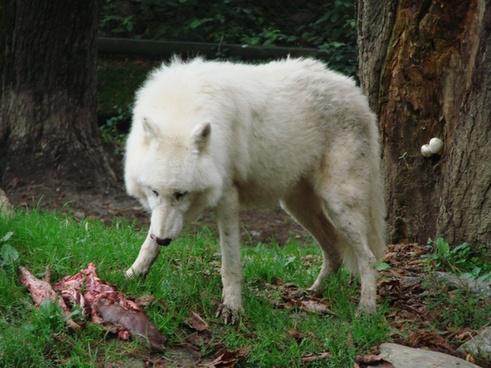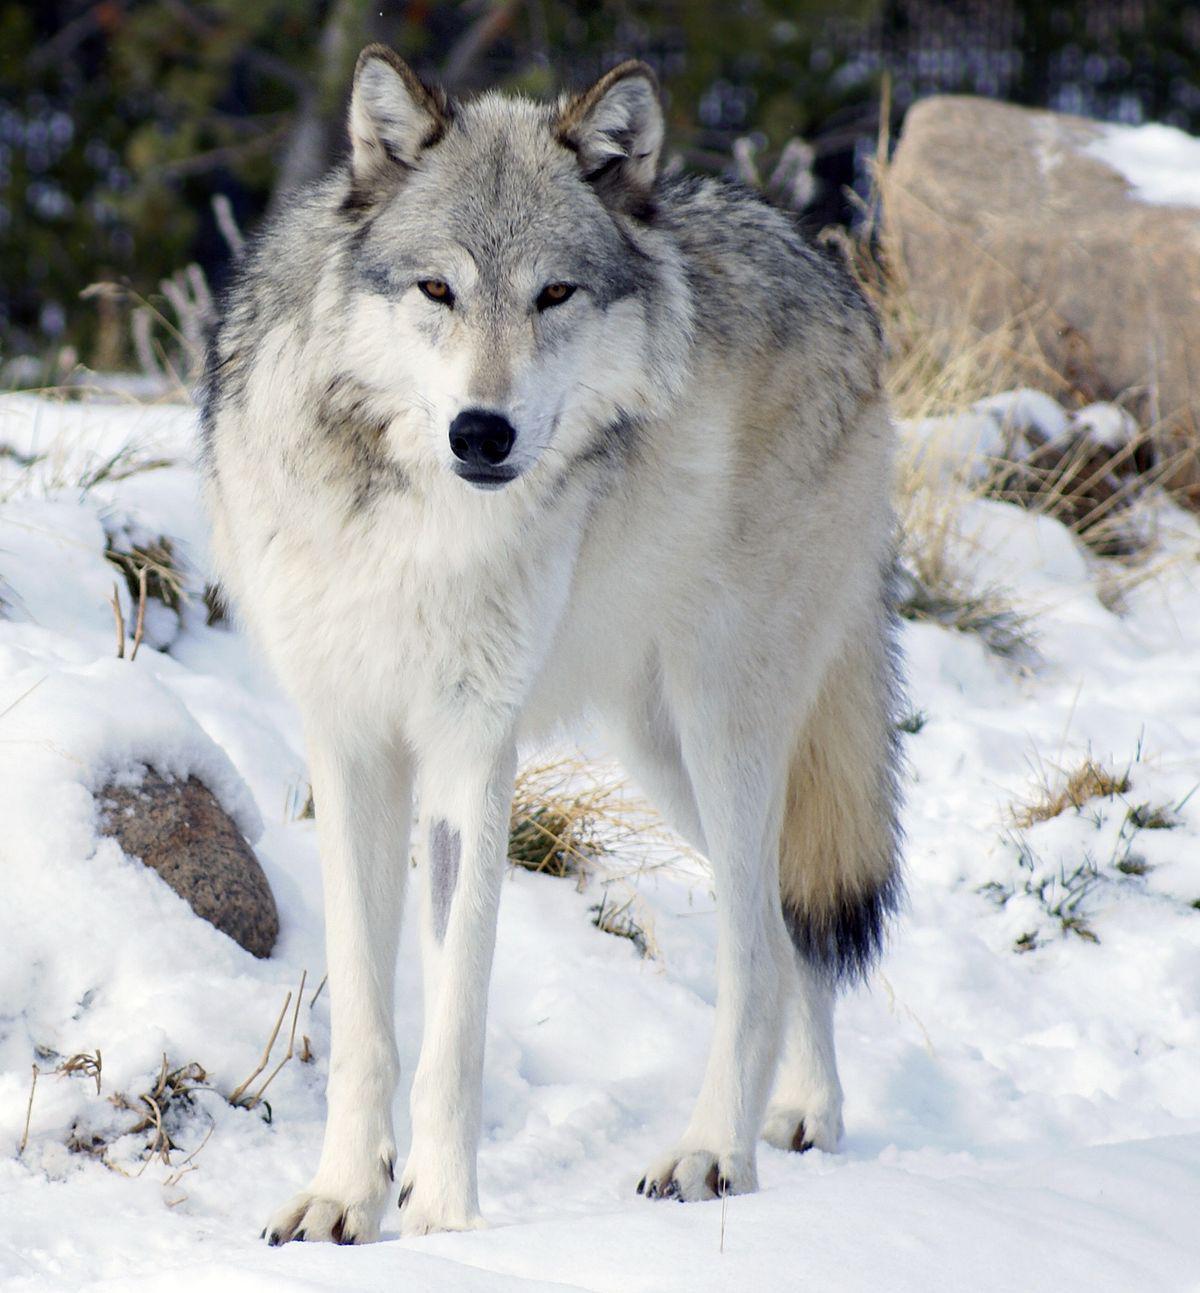The first image is the image on the left, the second image is the image on the right. For the images shown, is this caption "An image shows a wolf standing with its head bent down, behind part of a carcass." true? Answer yes or no. Yes. The first image is the image on the left, the second image is the image on the right. Evaluate the accuracy of this statement regarding the images: "At least one wolf is hovering over dead prey.". Is it true? Answer yes or no. Yes. 